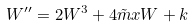<formula> <loc_0><loc_0><loc_500><loc_500>W ^ { \prime \prime } = 2 W ^ { 3 } + 4 \tilde { m } x W + k</formula> 